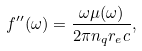Convert formula to latex. <formula><loc_0><loc_0><loc_500><loc_500>f ^ { \prime \prime } ( \omega ) = \frac { \omega \mu ( \omega ) } { 2 \pi n _ { q } r _ { e } c } ,</formula> 